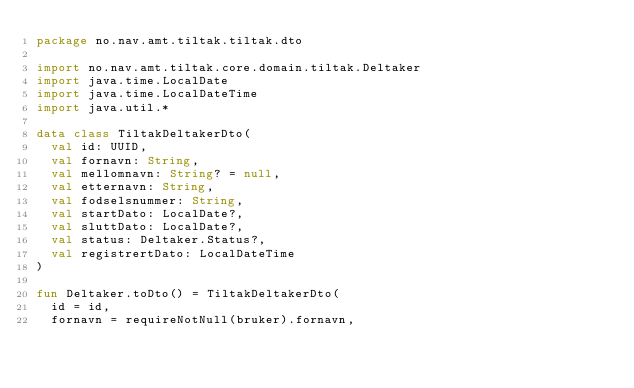Convert code to text. <code><loc_0><loc_0><loc_500><loc_500><_Kotlin_>package no.nav.amt.tiltak.tiltak.dto

import no.nav.amt.tiltak.core.domain.tiltak.Deltaker
import java.time.LocalDate
import java.time.LocalDateTime
import java.util.*

data class TiltakDeltakerDto(
	val id: UUID,
	val fornavn: String,
	val mellomnavn: String? = null,
	val etternavn: String,
	val fodselsnummer: String,
	val startDato: LocalDate?,
	val sluttDato: LocalDate?,
	val status: Deltaker.Status?,
	val registrertDato: LocalDateTime
)

fun Deltaker.toDto() = TiltakDeltakerDto(
	id = id,
	fornavn = requireNotNull(bruker).fornavn,</code> 